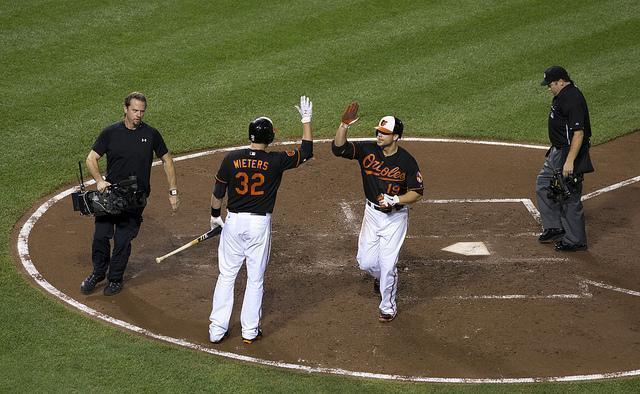Where did 19 just step away from?
Choose the right answer from the provided options to respond to the question.
Options: Home base, bunker, bunk house, pitchers mound. Home base. What category of animal is their mascot in?
From the following four choices, select the correct answer to address the question.
Options: Snake, cat, bird, dog. Bird. 